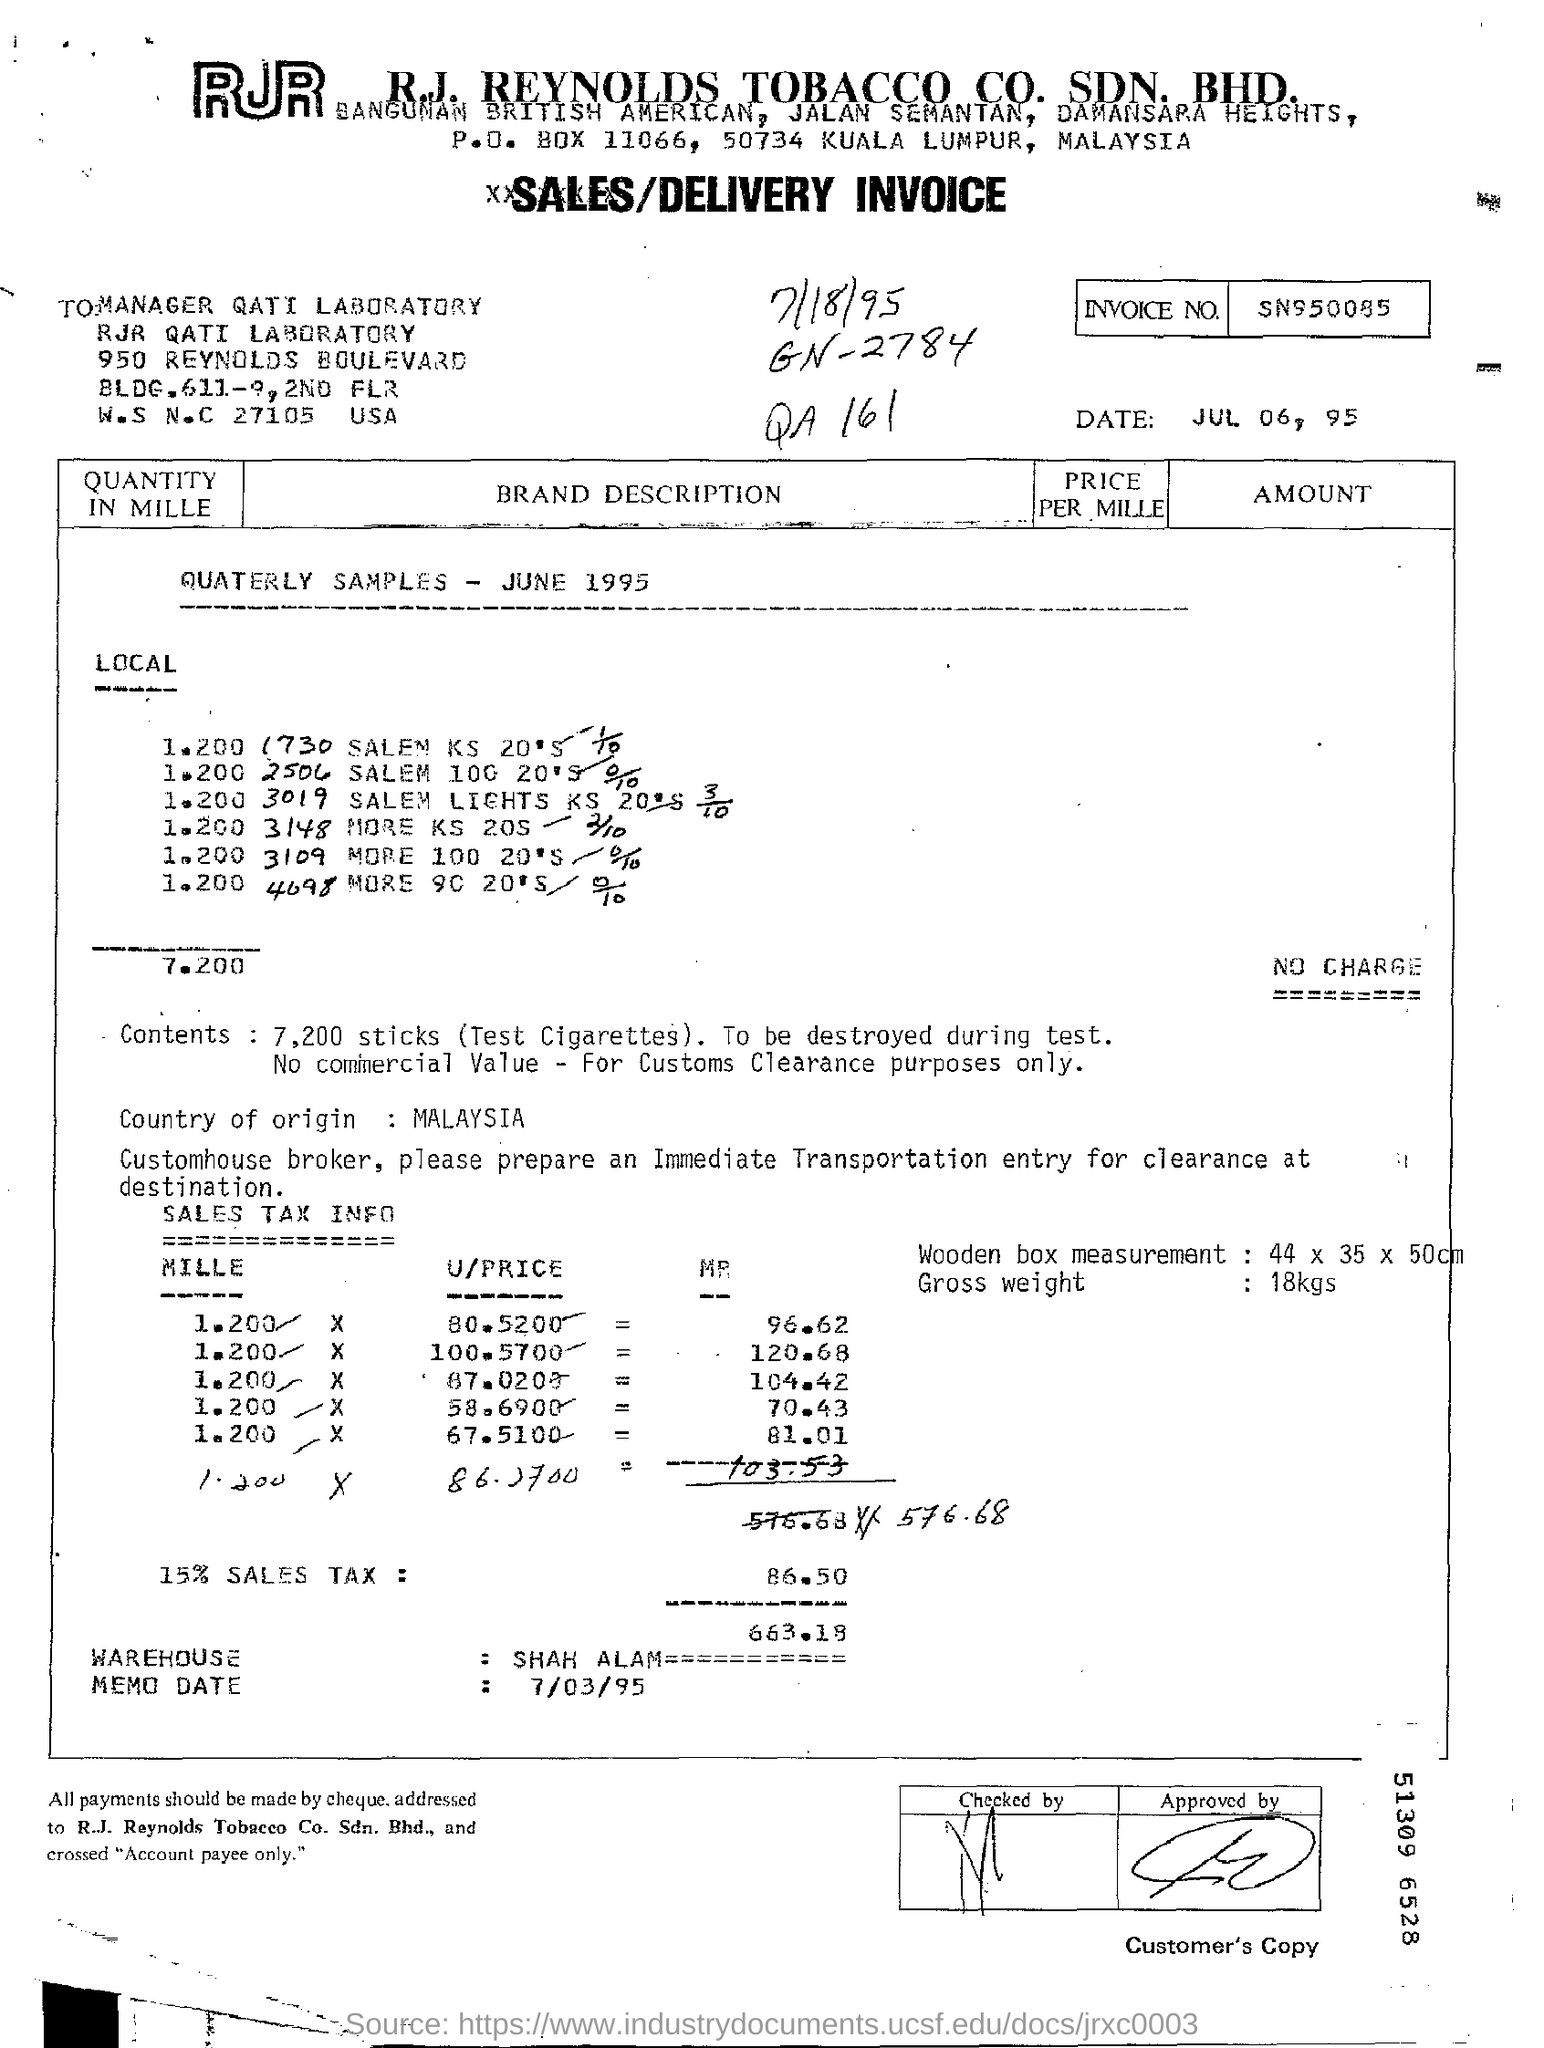Mention a couple of crucial points in this snapshot. The memo date is July 3, 1995. The shipment weighs a gross 18 kilograms. The sales tax percentage is 15%. The company name is R.J. Reynolds. The GN Number is a unique identifier assigned to a specific item, such as a book, by a library or other organization. For example, the GN Number for a book with the title "What is GN Number ?" and an ISBN of 2784-xxxx-xxxx-xxxx would be "GN 2784 108-9". This number is used to organize and catalog the item in a consistent and standardized way. 